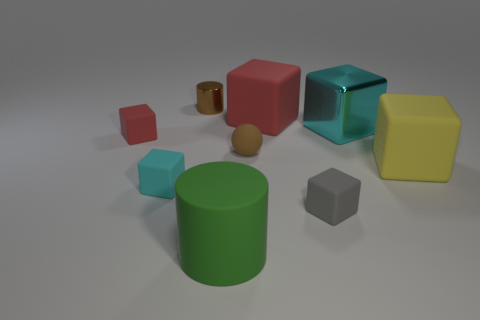Subtract all gray blocks. How many blocks are left? 5 Subtract all large cyan blocks. How many blocks are left? 5 Subtract all purple cubes. Subtract all gray cylinders. How many cubes are left? 6 Add 1 small gray rubber things. How many objects exist? 10 Subtract all cylinders. How many objects are left? 7 Add 6 tiny matte cubes. How many tiny matte cubes exist? 9 Subtract 0 green spheres. How many objects are left? 9 Subtract all tiny brown metal cylinders. Subtract all yellow matte things. How many objects are left? 7 Add 4 small gray blocks. How many small gray blocks are left? 5 